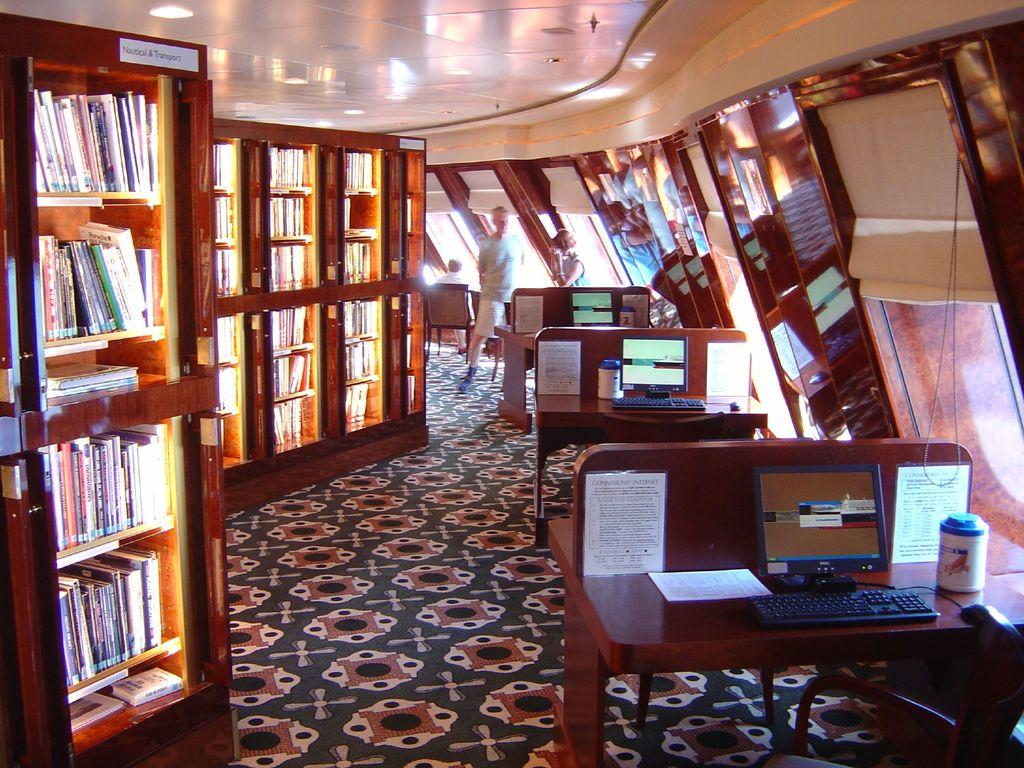What type of furniture is present in the image? There are desks in the image. What electronic devices are on the desks? There are computers on the desks. What type of storage furniture is in the image? There is a cupboard in the image. What items are stored inside the cupboard? The cupboard contains books. How does the ocean affect the desks in the image? The image does not depict an ocean or any water-related elements, so there is no effect on the desks. 